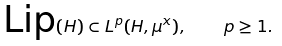Convert formula to latex. <formula><loc_0><loc_0><loc_500><loc_500>\text {Lip} ( H ) \subset L ^ { p } ( H , \mu ^ { x } ) , \quad p \geq 1 .</formula> 